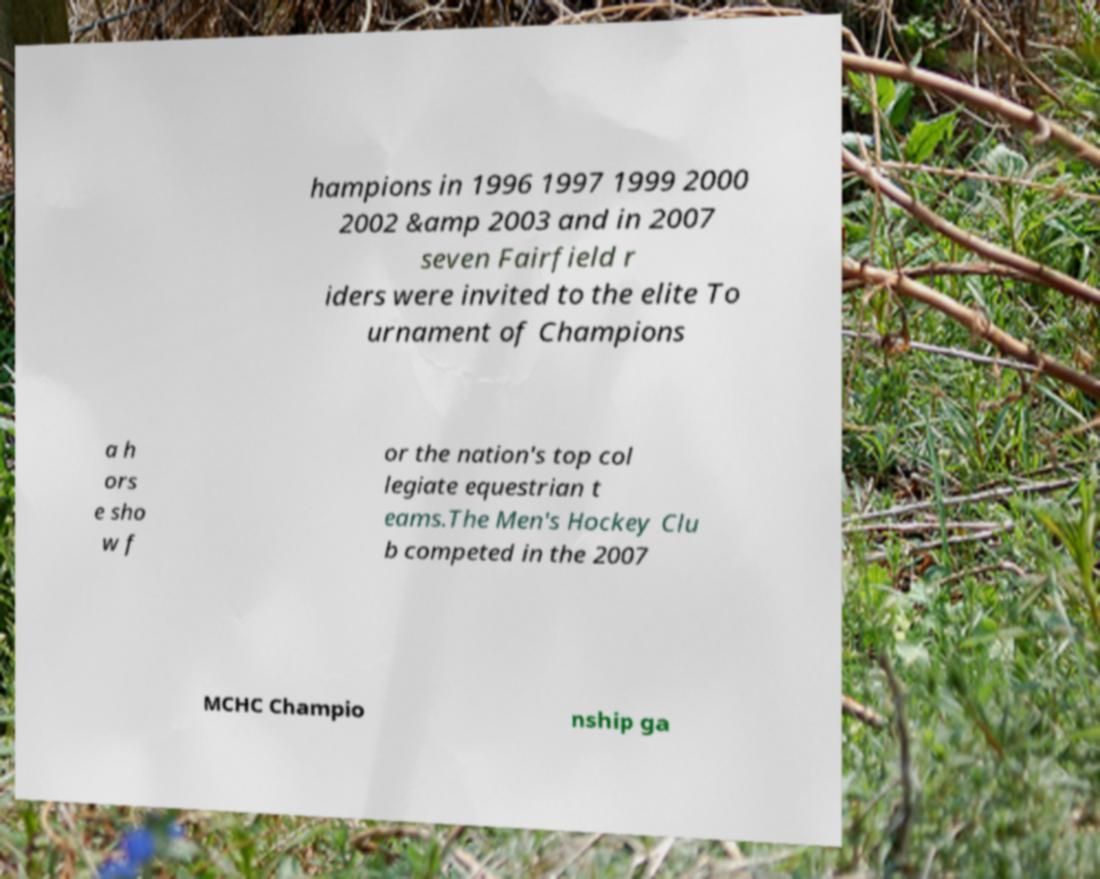Could you extract and type out the text from this image? hampions in 1996 1997 1999 2000 2002 &amp 2003 and in 2007 seven Fairfield r iders were invited to the elite To urnament of Champions a h ors e sho w f or the nation's top col legiate equestrian t eams.The Men's Hockey Clu b competed in the 2007 MCHC Champio nship ga 